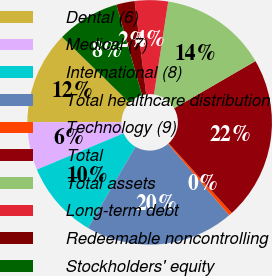Convert chart. <chart><loc_0><loc_0><loc_500><loc_500><pie_chart><fcel>Dental (6)<fcel>Medical (7)<fcel>International (8)<fcel>Total healthcare distribution<fcel>Technology (9)<fcel>Total<fcel>Total assets<fcel>Long-term debt<fcel>Redeemable noncontrolling<fcel>Stockholders' equity<nl><fcel>12.25%<fcel>6.35%<fcel>10.29%<fcel>19.67%<fcel>0.45%<fcel>21.64%<fcel>14.22%<fcel>4.39%<fcel>2.42%<fcel>8.32%<nl></chart> 